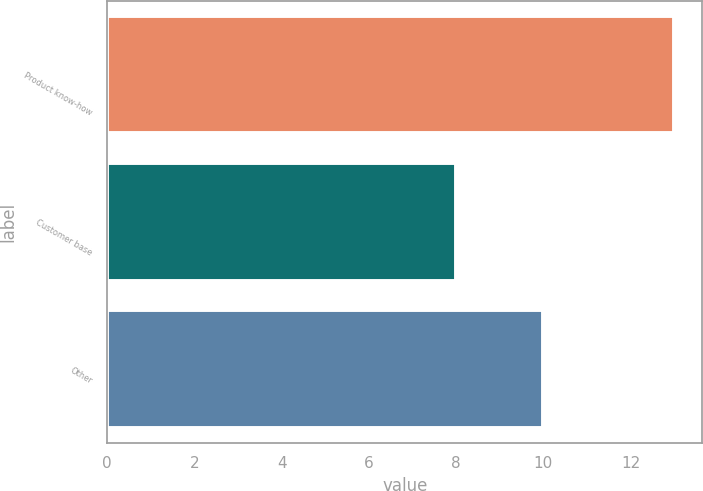Convert chart to OTSL. <chart><loc_0><loc_0><loc_500><loc_500><bar_chart><fcel>Product know-how<fcel>Customer base<fcel>Other<nl><fcel>13<fcel>8<fcel>10<nl></chart> 